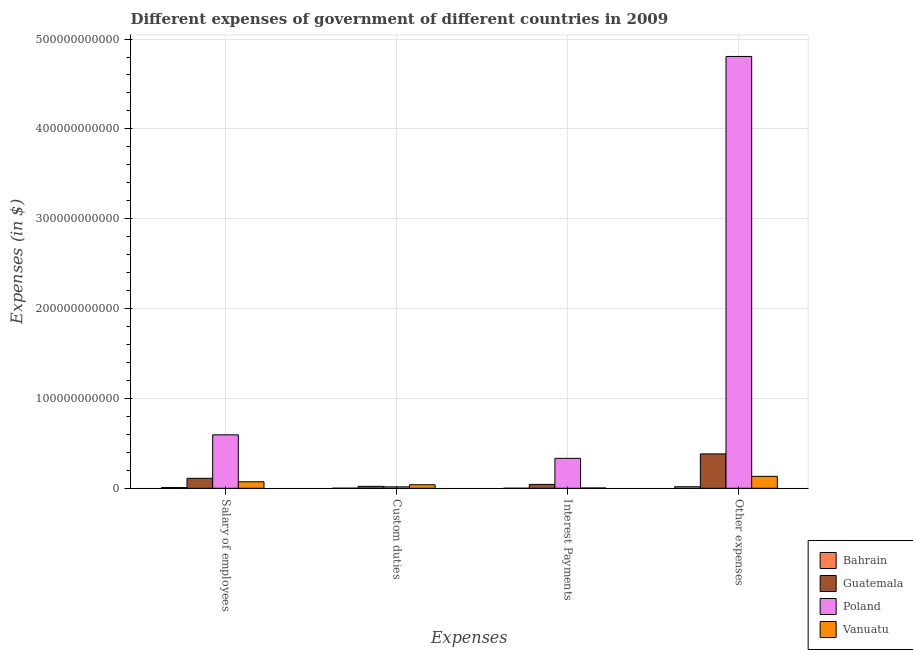How many different coloured bars are there?
Offer a terse response. 4. How many groups of bars are there?
Give a very brief answer. 4. Are the number of bars on each tick of the X-axis equal?
Your answer should be compact. Yes. How many bars are there on the 2nd tick from the left?
Ensure brevity in your answer.  4. What is the label of the 2nd group of bars from the left?
Provide a short and direct response. Custom duties. What is the amount spent on other expenses in Poland?
Make the answer very short. 4.81e+11. Across all countries, what is the maximum amount spent on other expenses?
Your response must be concise. 4.81e+11. Across all countries, what is the minimum amount spent on other expenses?
Your answer should be very brief. 1.70e+09. In which country was the amount spent on other expenses minimum?
Keep it short and to the point. Bahrain. What is the total amount spent on interest payments in the graph?
Make the answer very short. 3.80e+1. What is the difference between the amount spent on salary of employees in Vanuatu and that in Guatemala?
Your answer should be very brief. -3.87e+09. What is the difference between the amount spent on salary of employees in Vanuatu and the amount spent on interest payments in Bahrain?
Your answer should be compact. 7.19e+09. What is the average amount spent on salary of employees per country?
Offer a very short reply. 1.97e+1. What is the difference between the amount spent on other expenses and amount spent on custom duties in Poland?
Provide a succinct answer. 4.79e+11. What is the ratio of the amount spent on custom duties in Guatemala to that in Bahrain?
Keep it short and to the point. 25.67. Is the amount spent on custom duties in Guatemala less than that in Poland?
Provide a short and direct response. No. Is the difference between the amount spent on custom duties in Guatemala and Poland greater than the difference between the amount spent on salary of employees in Guatemala and Poland?
Keep it short and to the point. Yes. What is the difference between the highest and the second highest amount spent on interest payments?
Your answer should be very brief. 2.90e+1. What is the difference between the highest and the lowest amount spent on interest payments?
Give a very brief answer. 3.33e+1. Is the sum of the amount spent on other expenses in Bahrain and Guatemala greater than the maximum amount spent on custom duties across all countries?
Provide a short and direct response. Yes. What does the 1st bar from the left in Salary of employees represents?
Offer a very short reply. Bahrain. What does the 1st bar from the right in Custom duties represents?
Offer a terse response. Vanuatu. How many bars are there?
Give a very brief answer. 16. Are all the bars in the graph horizontal?
Your response must be concise. No. What is the difference between two consecutive major ticks on the Y-axis?
Give a very brief answer. 1.00e+11. Are the values on the major ticks of Y-axis written in scientific E-notation?
Provide a succinct answer. No. Does the graph contain any zero values?
Your response must be concise. No. Where does the legend appear in the graph?
Offer a terse response. Bottom right. How are the legend labels stacked?
Ensure brevity in your answer.  Vertical. What is the title of the graph?
Ensure brevity in your answer.  Different expenses of government of different countries in 2009. What is the label or title of the X-axis?
Ensure brevity in your answer.  Expenses. What is the label or title of the Y-axis?
Provide a succinct answer. Expenses (in $). What is the Expenses (in $) in Bahrain in Salary of employees?
Make the answer very short. 8.00e+08. What is the Expenses (in $) in Guatemala in Salary of employees?
Your answer should be compact. 1.11e+1. What is the Expenses (in $) of Poland in Salary of employees?
Keep it short and to the point. 5.95e+1. What is the Expenses (in $) of Vanuatu in Salary of employees?
Offer a terse response. 7.24e+09. What is the Expenses (in $) of Bahrain in Custom duties?
Offer a very short reply. 8.33e+07. What is the Expenses (in $) of Guatemala in Custom duties?
Make the answer very short. 2.14e+09. What is the Expenses (in $) in Poland in Custom duties?
Your answer should be compact. 1.59e+09. What is the Expenses (in $) of Vanuatu in Custom duties?
Provide a succinct answer. 3.91e+09. What is the Expenses (in $) in Bahrain in Interest Payments?
Your answer should be compact. 5.00e+07. What is the Expenses (in $) of Guatemala in Interest Payments?
Provide a succinct answer. 4.30e+09. What is the Expenses (in $) in Poland in Interest Payments?
Make the answer very short. 3.33e+1. What is the Expenses (in $) of Vanuatu in Interest Payments?
Ensure brevity in your answer.  3.18e+08. What is the Expenses (in $) of Bahrain in Other expenses?
Provide a succinct answer. 1.70e+09. What is the Expenses (in $) of Guatemala in Other expenses?
Provide a short and direct response. 3.82e+1. What is the Expenses (in $) in Poland in Other expenses?
Your answer should be compact. 4.81e+11. What is the Expenses (in $) in Vanuatu in Other expenses?
Offer a very short reply. 1.33e+1. Across all Expenses, what is the maximum Expenses (in $) in Bahrain?
Make the answer very short. 1.70e+09. Across all Expenses, what is the maximum Expenses (in $) of Guatemala?
Offer a terse response. 3.82e+1. Across all Expenses, what is the maximum Expenses (in $) in Poland?
Offer a very short reply. 4.81e+11. Across all Expenses, what is the maximum Expenses (in $) of Vanuatu?
Your answer should be very brief. 1.33e+1. Across all Expenses, what is the minimum Expenses (in $) in Bahrain?
Your answer should be compact. 5.00e+07. Across all Expenses, what is the minimum Expenses (in $) of Guatemala?
Offer a very short reply. 2.14e+09. Across all Expenses, what is the minimum Expenses (in $) of Poland?
Make the answer very short. 1.59e+09. Across all Expenses, what is the minimum Expenses (in $) of Vanuatu?
Your answer should be compact. 3.18e+08. What is the total Expenses (in $) in Bahrain in the graph?
Your response must be concise. 2.64e+09. What is the total Expenses (in $) of Guatemala in the graph?
Keep it short and to the point. 5.58e+1. What is the total Expenses (in $) in Poland in the graph?
Offer a terse response. 5.75e+11. What is the total Expenses (in $) of Vanuatu in the graph?
Offer a terse response. 2.47e+1. What is the difference between the Expenses (in $) in Bahrain in Salary of employees and that in Custom duties?
Your answer should be very brief. 7.17e+08. What is the difference between the Expenses (in $) of Guatemala in Salary of employees and that in Custom duties?
Make the answer very short. 8.96e+09. What is the difference between the Expenses (in $) in Poland in Salary of employees and that in Custom duties?
Offer a very short reply. 5.79e+1. What is the difference between the Expenses (in $) in Vanuatu in Salary of employees and that in Custom duties?
Your answer should be very brief. 3.33e+09. What is the difference between the Expenses (in $) in Bahrain in Salary of employees and that in Interest Payments?
Keep it short and to the point. 7.50e+08. What is the difference between the Expenses (in $) in Guatemala in Salary of employees and that in Interest Payments?
Give a very brief answer. 6.81e+09. What is the difference between the Expenses (in $) in Poland in Salary of employees and that in Interest Payments?
Your answer should be compact. 2.62e+1. What is the difference between the Expenses (in $) in Vanuatu in Salary of employees and that in Interest Payments?
Offer a very short reply. 6.92e+09. What is the difference between the Expenses (in $) of Bahrain in Salary of employees and that in Other expenses?
Make the answer very short. -9.05e+08. What is the difference between the Expenses (in $) of Guatemala in Salary of employees and that in Other expenses?
Provide a succinct answer. -2.71e+1. What is the difference between the Expenses (in $) of Poland in Salary of employees and that in Other expenses?
Give a very brief answer. -4.21e+11. What is the difference between the Expenses (in $) in Vanuatu in Salary of employees and that in Other expenses?
Your answer should be very brief. -6.04e+09. What is the difference between the Expenses (in $) of Bahrain in Custom duties and that in Interest Payments?
Give a very brief answer. 3.33e+07. What is the difference between the Expenses (in $) of Guatemala in Custom duties and that in Interest Payments?
Provide a succinct answer. -2.16e+09. What is the difference between the Expenses (in $) in Poland in Custom duties and that in Interest Payments?
Offer a terse response. -3.17e+1. What is the difference between the Expenses (in $) in Vanuatu in Custom duties and that in Interest Payments?
Give a very brief answer. 3.59e+09. What is the difference between the Expenses (in $) in Bahrain in Custom duties and that in Other expenses?
Provide a short and direct response. -1.62e+09. What is the difference between the Expenses (in $) in Guatemala in Custom duties and that in Other expenses?
Provide a succinct answer. -3.61e+1. What is the difference between the Expenses (in $) of Poland in Custom duties and that in Other expenses?
Provide a succinct answer. -4.79e+11. What is the difference between the Expenses (in $) in Vanuatu in Custom duties and that in Other expenses?
Your response must be concise. -9.36e+09. What is the difference between the Expenses (in $) in Bahrain in Interest Payments and that in Other expenses?
Provide a short and direct response. -1.65e+09. What is the difference between the Expenses (in $) in Guatemala in Interest Payments and that in Other expenses?
Ensure brevity in your answer.  -3.39e+1. What is the difference between the Expenses (in $) of Poland in Interest Payments and that in Other expenses?
Your answer should be very brief. -4.47e+11. What is the difference between the Expenses (in $) of Vanuatu in Interest Payments and that in Other expenses?
Offer a terse response. -1.30e+1. What is the difference between the Expenses (in $) of Bahrain in Salary of employees and the Expenses (in $) of Guatemala in Custom duties?
Make the answer very short. -1.34e+09. What is the difference between the Expenses (in $) in Bahrain in Salary of employees and the Expenses (in $) in Poland in Custom duties?
Provide a short and direct response. -7.89e+08. What is the difference between the Expenses (in $) of Bahrain in Salary of employees and the Expenses (in $) of Vanuatu in Custom duties?
Ensure brevity in your answer.  -3.11e+09. What is the difference between the Expenses (in $) in Guatemala in Salary of employees and the Expenses (in $) in Poland in Custom duties?
Ensure brevity in your answer.  9.51e+09. What is the difference between the Expenses (in $) in Guatemala in Salary of employees and the Expenses (in $) in Vanuatu in Custom duties?
Provide a short and direct response. 7.20e+09. What is the difference between the Expenses (in $) of Poland in Salary of employees and the Expenses (in $) of Vanuatu in Custom duties?
Keep it short and to the point. 5.56e+1. What is the difference between the Expenses (in $) of Bahrain in Salary of employees and the Expenses (in $) of Guatemala in Interest Payments?
Offer a terse response. -3.50e+09. What is the difference between the Expenses (in $) in Bahrain in Salary of employees and the Expenses (in $) in Poland in Interest Payments?
Provide a short and direct response. -3.25e+1. What is the difference between the Expenses (in $) of Bahrain in Salary of employees and the Expenses (in $) of Vanuatu in Interest Payments?
Offer a terse response. 4.82e+08. What is the difference between the Expenses (in $) in Guatemala in Salary of employees and the Expenses (in $) in Poland in Interest Payments?
Offer a terse response. -2.22e+1. What is the difference between the Expenses (in $) of Guatemala in Salary of employees and the Expenses (in $) of Vanuatu in Interest Payments?
Make the answer very short. 1.08e+1. What is the difference between the Expenses (in $) of Poland in Salary of employees and the Expenses (in $) of Vanuatu in Interest Payments?
Your answer should be very brief. 5.92e+1. What is the difference between the Expenses (in $) in Bahrain in Salary of employees and the Expenses (in $) in Guatemala in Other expenses?
Your answer should be compact. -3.74e+1. What is the difference between the Expenses (in $) in Bahrain in Salary of employees and the Expenses (in $) in Poland in Other expenses?
Your answer should be compact. -4.80e+11. What is the difference between the Expenses (in $) of Bahrain in Salary of employees and the Expenses (in $) of Vanuatu in Other expenses?
Ensure brevity in your answer.  -1.25e+1. What is the difference between the Expenses (in $) of Guatemala in Salary of employees and the Expenses (in $) of Poland in Other expenses?
Keep it short and to the point. -4.70e+11. What is the difference between the Expenses (in $) of Guatemala in Salary of employees and the Expenses (in $) of Vanuatu in Other expenses?
Offer a terse response. -2.17e+09. What is the difference between the Expenses (in $) of Poland in Salary of employees and the Expenses (in $) of Vanuatu in Other expenses?
Provide a succinct answer. 4.62e+1. What is the difference between the Expenses (in $) of Bahrain in Custom duties and the Expenses (in $) of Guatemala in Interest Payments?
Offer a very short reply. -4.21e+09. What is the difference between the Expenses (in $) in Bahrain in Custom duties and the Expenses (in $) in Poland in Interest Payments?
Your answer should be compact. -3.32e+1. What is the difference between the Expenses (in $) of Bahrain in Custom duties and the Expenses (in $) of Vanuatu in Interest Payments?
Keep it short and to the point. -2.34e+08. What is the difference between the Expenses (in $) in Guatemala in Custom duties and the Expenses (in $) in Poland in Interest Payments?
Your response must be concise. -3.12e+1. What is the difference between the Expenses (in $) of Guatemala in Custom duties and the Expenses (in $) of Vanuatu in Interest Payments?
Ensure brevity in your answer.  1.82e+09. What is the difference between the Expenses (in $) in Poland in Custom duties and the Expenses (in $) in Vanuatu in Interest Payments?
Keep it short and to the point. 1.27e+09. What is the difference between the Expenses (in $) of Bahrain in Custom duties and the Expenses (in $) of Guatemala in Other expenses?
Your answer should be compact. -3.82e+1. What is the difference between the Expenses (in $) of Bahrain in Custom duties and the Expenses (in $) of Poland in Other expenses?
Your response must be concise. -4.81e+11. What is the difference between the Expenses (in $) of Bahrain in Custom duties and the Expenses (in $) of Vanuatu in Other expenses?
Give a very brief answer. -1.32e+1. What is the difference between the Expenses (in $) in Guatemala in Custom duties and the Expenses (in $) in Poland in Other expenses?
Your answer should be very brief. -4.78e+11. What is the difference between the Expenses (in $) of Guatemala in Custom duties and the Expenses (in $) of Vanuatu in Other expenses?
Offer a terse response. -1.11e+1. What is the difference between the Expenses (in $) in Poland in Custom duties and the Expenses (in $) in Vanuatu in Other expenses?
Your answer should be compact. -1.17e+1. What is the difference between the Expenses (in $) of Bahrain in Interest Payments and the Expenses (in $) of Guatemala in Other expenses?
Provide a short and direct response. -3.82e+1. What is the difference between the Expenses (in $) of Bahrain in Interest Payments and the Expenses (in $) of Poland in Other expenses?
Your answer should be very brief. -4.81e+11. What is the difference between the Expenses (in $) of Bahrain in Interest Payments and the Expenses (in $) of Vanuatu in Other expenses?
Ensure brevity in your answer.  -1.32e+1. What is the difference between the Expenses (in $) in Guatemala in Interest Payments and the Expenses (in $) in Poland in Other expenses?
Keep it short and to the point. -4.76e+11. What is the difference between the Expenses (in $) of Guatemala in Interest Payments and the Expenses (in $) of Vanuatu in Other expenses?
Offer a terse response. -8.98e+09. What is the difference between the Expenses (in $) in Poland in Interest Payments and the Expenses (in $) in Vanuatu in Other expenses?
Offer a terse response. 2.01e+1. What is the average Expenses (in $) of Bahrain per Expenses?
Your response must be concise. 6.59e+08. What is the average Expenses (in $) in Guatemala per Expenses?
Provide a succinct answer. 1.39e+1. What is the average Expenses (in $) of Poland per Expenses?
Your response must be concise. 1.44e+11. What is the average Expenses (in $) of Vanuatu per Expenses?
Offer a terse response. 6.18e+09. What is the difference between the Expenses (in $) of Bahrain and Expenses (in $) of Guatemala in Salary of employees?
Give a very brief answer. -1.03e+1. What is the difference between the Expenses (in $) in Bahrain and Expenses (in $) in Poland in Salary of employees?
Keep it short and to the point. -5.87e+1. What is the difference between the Expenses (in $) in Bahrain and Expenses (in $) in Vanuatu in Salary of employees?
Your answer should be very brief. -6.44e+09. What is the difference between the Expenses (in $) of Guatemala and Expenses (in $) of Poland in Salary of employees?
Ensure brevity in your answer.  -4.84e+1. What is the difference between the Expenses (in $) in Guatemala and Expenses (in $) in Vanuatu in Salary of employees?
Give a very brief answer. 3.87e+09. What is the difference between the Expenses (in $) of Poland and Expenses (in $) of Vanuatu in Salary of employees?
Offer a terse response. 5.23e+1. What is the difference between the Expenses (in $) of Bahrain and Expenses (in $) of Guatemala in Custom duties?
Ensure brevity in your answer.  -2.06e+09. What is the difference between the Expenses (in $) in Bahrain and Expenses (in $) in Poland in Custom duties?
Offer a terse response. -1.51e+09. What is the difference between the Expenses (in $) of Bahrain and Expenses (in $) of Vanuatu in Custom duties?
Provide a short and direct response. -3.82e+09. What is the difference between the Expenses (in $) in Guatemala and Expenses (in $) in Poland in Custom duties?
Keep it short and to the point. 5.50e+08. What is the difference between the Expenses (in $) in Guatemala and Expenses (in $) in Vanuatu in Custom duties?
Offer a terse response. -1.77e+09. What is the difference between the Expenses (in $) in Poland and Expenses (in $) in Vanuatu in Custom duties?
Give a very brief answer. -2.32e+09. What is the difference between the Expenses (in $) of Bahrain and Expenses (in $) of Guatemala in Interest Payments?
Offer a very short reply. -4.25e+09. What is the difference between the Expenses (in $) of Bahrain and Expenses (in $) of Poland in Interest Payments?
Your response must be concise. -3.33e+1. What is the difference between the Expenses (in $) of Bahrain and Expenses (in $) of Vanuatu in Interest Payments?
Give a very brief answer. -2.68e+08. What is the difference between the Expenses (in $) in Guatemala and Expenses (in $) in Poland in Interest Payments?
Provide a succinct answer. -2.90e+1. What is the difference between the Expenses (in $) in Guatemala and Expenses (in $) in Vanuatu in Interest Payments?
Make the answer very short. 3.98e+09. What is the difference between the Expenses (in $) in Poland and Expenses (in $) in Vanuatu in Interest Payments?
Keep it short and to the point. 3.30e+1. What is the difference between the Expenses (in $) in Bahrain and Expenses (in $) in Guatemala in Other expenses?
Ensure brevity in your answer.  -3.65e+1. What is the difference between the Expenses (in $) in Bahrain and Expenses (in $) in Poland in Other expenses?
Your answer should be compact. -4.79e+11. What is the difference between the Expenses (in $) in Bahrain and Expenses (in $) in Vanuatu in Other expenses?
Offer a very short reply. -1.16e+1. What is the difference between the Expenses (in $) of Guatemala and Expenses (in $) of Poland in Other expenses?
Keep it short and to the point. -4.42e+11. What is the difference between the Expenses (in $) of Guatemala and Expenses (in $) of Vanuatu in Other expenses?
Make the answer very short. 2.50e+1. What is the difference between the Expenses (in $) in Poland and Expenses (in $) in Vanuatu in Other expenses?
Provide a succinct answer. 4.67e+11. What is the ratio of the Expenses (in $) of Bahrain in Salary of employees to that in Custom duties?
Keep it short and to the point. 9.6. What is the ratio of the Expenses (in $) in Guatemala in Salary of employees to that in Custom duties?
Ensure brevity in your answer.  5.19. What is the ratio of the Expenses (in $) in Poland in Salary of employees to that in Custom duties?
Keep it short and to the point. 37.44. What is the ratio of the Expenses (in $) of Vanuatu in Salary of employees to that in Custom duties?
Provide a short and direct response. 1.85. What is the ratio of the Expenses (in $) of Bahrain in Salary of employees to that in Interest Payments?
Offer a very short reply. 15.98. What is the ratio of the Expenses (in $) of Guatemala in Salary of employees to that in Interest Payments?
Keep it short and to the point. 2.58. What is the ratio of the Expenses (in $) in Poland in Salary of employees to that in Interest Payments?
Make the answer very short. 1.79. What is the ratio of the Expenses (in $) of Vanuatu in Salary of employees to that in Interest Payments?
Make the answer very short. 22.77. What is the ratio of the Expenses (in $) of Bahrain in Salary of employees to that in Other expenses?
Your answer should be compact. 0.47. What is the ratio of the Expenses (in $) of Guatemala in Salary of employees to that in Other expenses?
Your response must be concise. 0.29. What is the ratio of the Expenses (in $) in Poland in Salary of employees to that in Other expenses?
Your answer should be very brief. 0.12. What is the ratio of the Expenses (in $) in Vanuatu in Salary of employees to that in Other expenses?
Ensure brevity in your answer.  0.55. What is the ratio of the Expenses (in $) of Bahrain in Custom duties to that in Interest Payments?
Provide a succinct answer. 1.66. What is the ratio of the Expenses (in $) in Guatemala in Custom duties to that in Interest Payments?
Your response must be concise. 0.5. What is the ratio of the Expenses (in $) in Poland in Custom duties to that in Interest Payments?
Make the answer very short. 0.05. What is the ratio of the Expenses (in $) in Vanuatu in Custom duties to that in Interest Payments?
Offer a very short reply. 12.3. What is the ratio of the Expenses (in $) in Bahrain in Custom duties to that in Other expenses?
Your response must be concise. 0.05. What is the ratio of the Expenses (in $) of Guatemala in Custom duties to that in Other expenses?
Offer a terse response. 0.06. What is the ratio of the Expenses (in $) in Poland in Custom duties to that in Other expenses?
Your answer should be very brief. 0. What is the ratio of the Expenses (in $) of Vanuatu in Custom duties to that in Other expenses?
Offer a very short reply. 0.29. What is the ratio of the Expenses (in $) in Bahrain in Interest Payments to that in Other expenses?
Offer a terse response. 0.03. What is the ratio of the Expenses (in $) of Guatemala in Interest Payments to that in Other expenses?
Keep it short and to the point. 0.11. What is the ratio of the Expenses (in $) of Poland in Interest Payments to that in Other expenses?
Provide a short and direct response. 0.07. What is the ratio of the Expenses (in $) in Vanuatu in Interest Payments to that in Other expenses?
Your response must be concise. 0.02. What is the difference between the highest and the second highest Expenses (in $) of Bahrain?
Give a very brief answer. 9.05e+08. What is the difference between the highest and the second highest Expenses (in $) of Guatemala?
Provide a short and direct response. 2.71e+1. What is the difference between the highest and the second highest Expenses (in $) of Poland?
Provide a short and direct response. 4.21e+11. What is the difference between the highest and the second highest Expenses (in $) of Vanuatu?
Ensure brevity in your answer.  6.04e+09. What is the difference between the highest and the lowest Expenses (in $) of Bahrain?
Offer a very short reply. 1.65e+09. What is the difference between the highest and the lowest Expenses (in $) of Guatemala?
Provide a short and direct response. 3.61e+1. What is the difference between the highest and the lowest Expenses (in $) in Poland?
Offer a very short reply. 4.79e+11. What is the difference between the highest and the lowest Expenses (in $) of Vanuatu?
Your answer should be compact. 1.30e+1. 